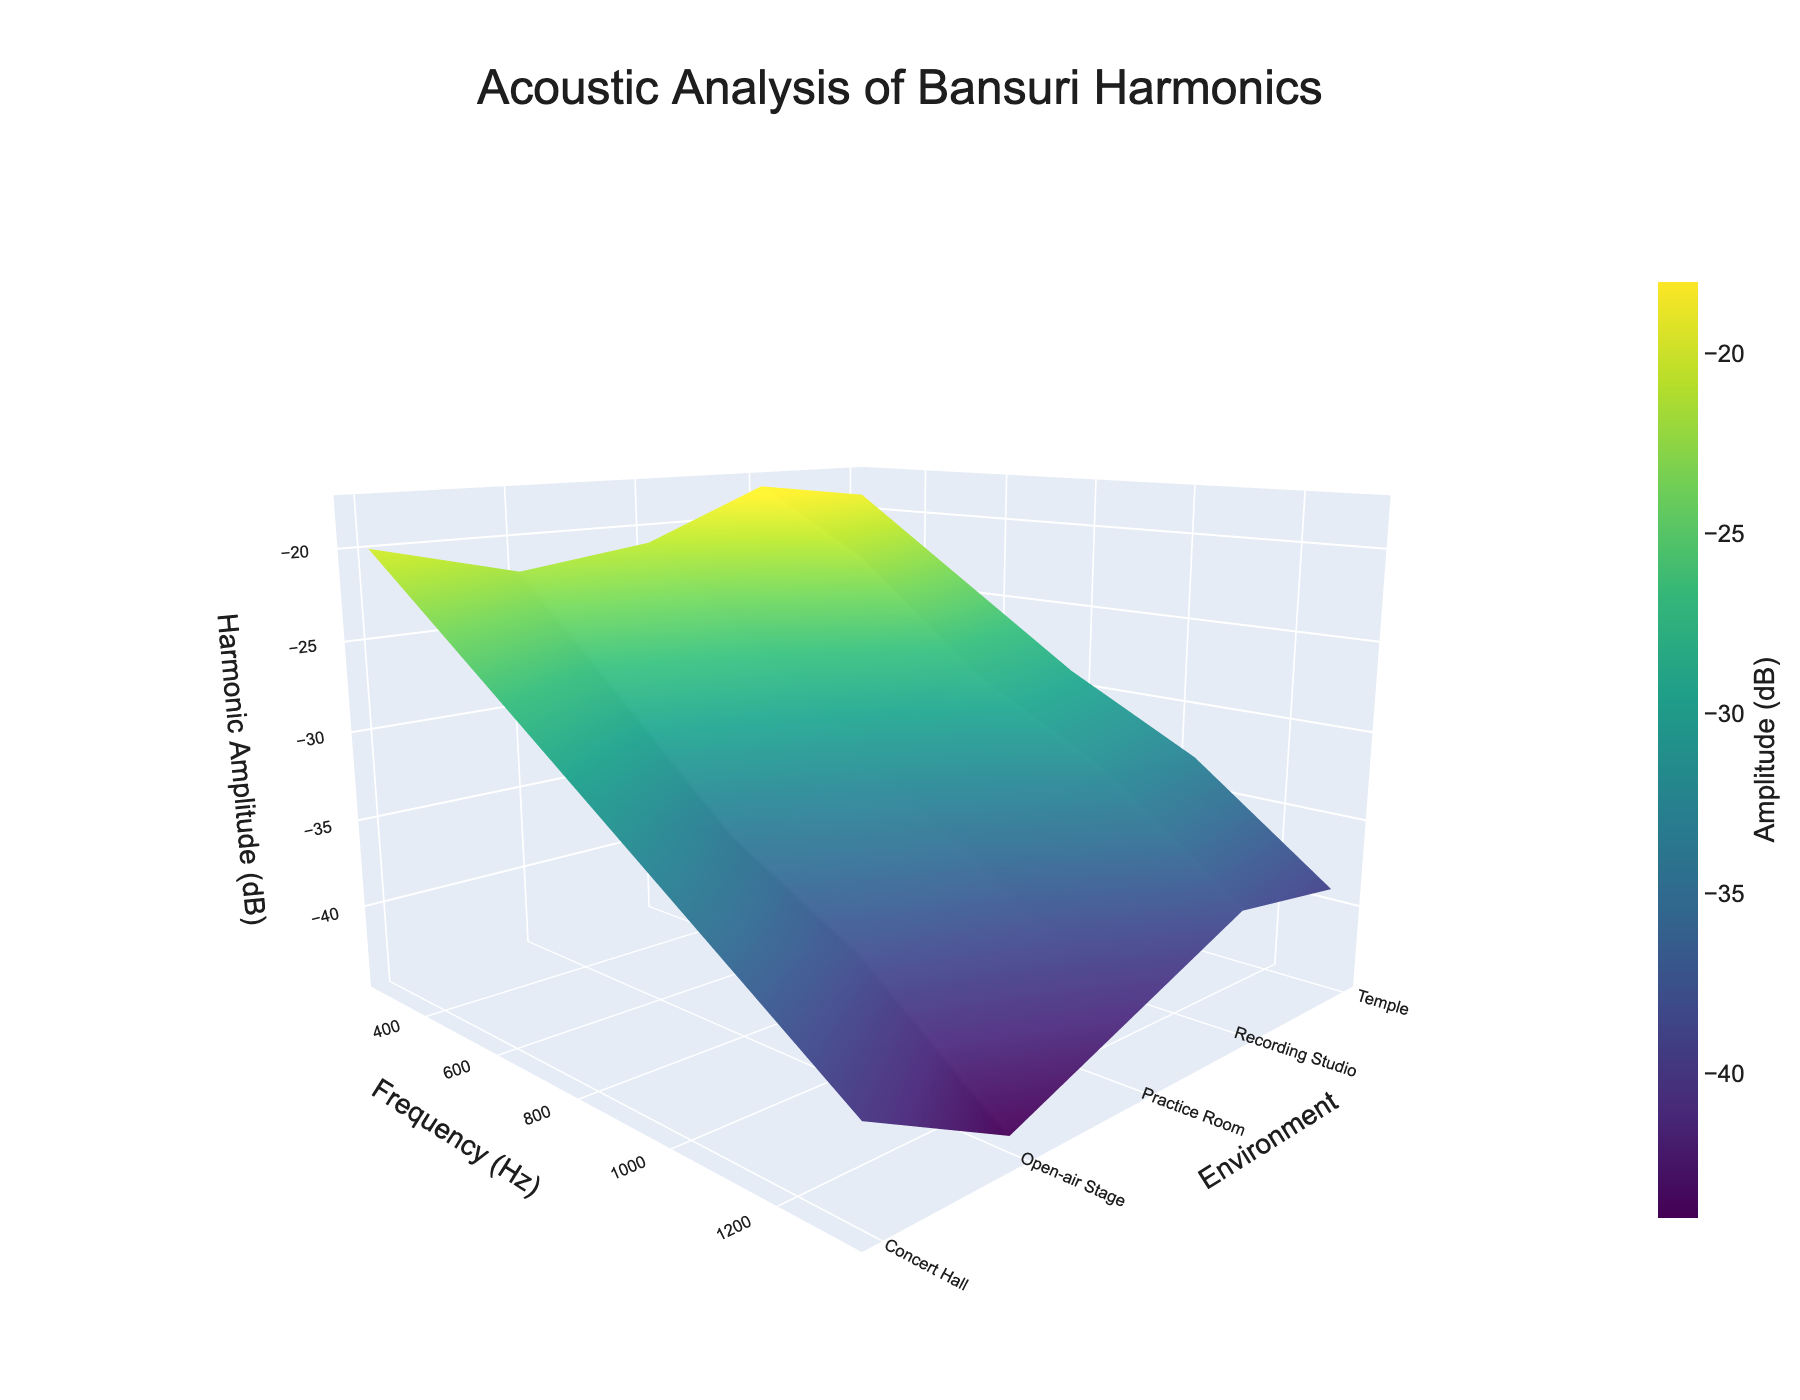What is the title of the plot? The title of the plot is clearly indicated at the top of the figure, highlighting the subject of the acoustic analysis performed.
Answer: Acoustic Analysis of Bansuri Harmonics What are the axes labels for the plot? The axes labels are provided to indicate what each axis represents in the 3D space of the plot. The x-axis signifies frequency in Hz, the y-axis signifies environment, and the z-axis signifies harmonic amplitude in dB.
Answer: Frequency (Hz), Environment, Harmonic Amplitude (dB) Which environment has the lowest harmonic amplitude at 784.8 Hz? To determine this, look along the z-axis values at the 784.8 Hz frequency axis on the surface plot and find the environment corresponding to the lowest point on the z-axis.
Answer: Open-air Stage How does the harmonic amplitude change in the Recording Studio environment as the frequency increases? Observe the trend of the z-axis values for the Recording Studio as you move from lower to higher frequencies along the x-axis. The amplitude decreases as frequency increases.
Answer: It decreases Which environment shows the most stable harmonic amplitude across all frequencies? Compare the surface plots of all environments for the smoothest or most level change along the z-axis across all frequencies. The environment with the least variation is the most stable.
Answer: Temple Between the Concert Hall and Open-air Stage, which environment has a higher harmonic amplitude at 261.6 Hz? Track the 261.6 Hz frequency along the x-axis and compare the heights on the z-axis (amplitude) between Concert Hall and Open-air Stage.
Answer: Concert Hall By how many decibels is the harmonic amplitude at 1046.4 Hz in the Practice Room lower than in the Recording Studio? Note the harmonic amplitudes at 1046.4 Hz for both environments and calculate the difference: 32 dB in Recording Studio and -36 dB in Practice Room.
Answer: 4 dB Which environment produces the lowest minimum harmonic amplitude? Look for the lowest points on the z-axis among all environments, and identify which is the minimum. The environment corresponding to this lowest point helps us identify the right answer.
Answer: Open-air Stage Is there any frequency where all environments have the same harmonic amplitude? Carefully observe the z-axis values across all environments at each frequency along the x-axis to check for any equal harmonic amplitudes.
Answer: No What is the overall trend in harmonic amplitude with increasing frequency for an environment of your choice? Select an environment and follow the surface plot along the x-axis (frequency) to observe how the z-axis (amplitude) changes. For example, in the Concert Hall, the harmonic amplitude steadily decreases with increasing frequency.
Answer: The harmonic amplitude decreases 